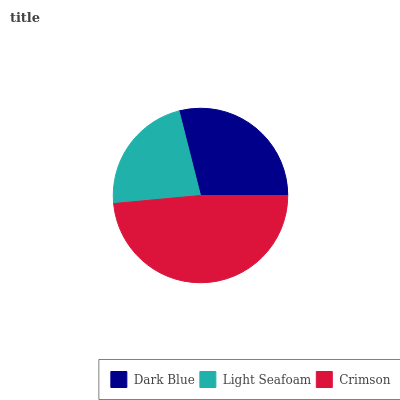Is Light Seafoam the minimum?
Answer yes or no. Yes. Is Crimson the maximum?
Answer yes or no. Yes. Is Crimson the minimum?
Answer yes or no. No. Is Light Seafoam the maximum?
Answer yes or no. No. Is Crimson greater than Light Seafoam?
Answer yes or no. Yes. Is Light Seafoam less than Crimson?
Answer yes or no. Yes. Is Light Seafoam greater than Crimson?
Answer yes or no. No. Is Crimson less than Light Seafoam?
Answer yes or no. No. Is Dark Blue the high median?
Answer yes or no. Yes. Is Dark Blue the low median?
Answer yes or no. Yes. Is Crimson the high median?
Answer yes or no. No. Is Crimson the low median?
Answer yes or no. No. 